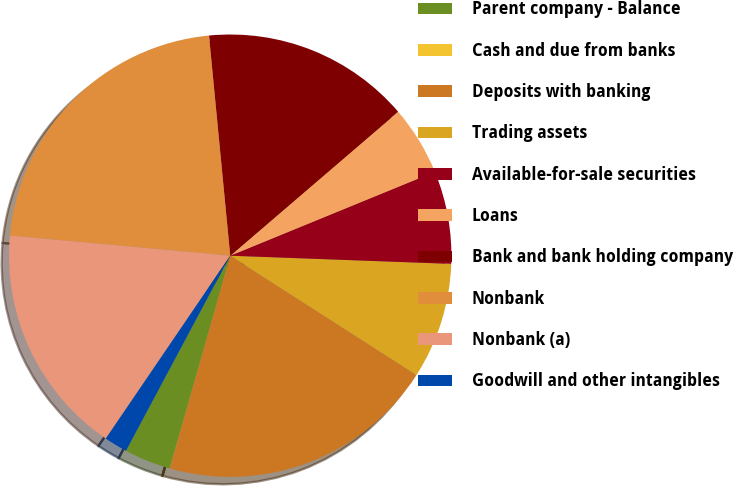Convert chart. <chart><loc_0><loc_0><loc_500><loc_500><pie_chart><fcel>Parent company - Balance<fcel>Cash and due from banks<fcel>Deposits with banking<fcel>Trading assets<fcel>Available-for-sale securities<fcel>Loans<fcel>Bank and bank holding company<fcel>Nonbank<fcel>Nonbank (a)<fcel>Goodwill and other intangibles<nl><fcel>3.4%<fcel>0.01%<fcel>20.33%<fcel>8.48%<fcel>6.78%<fcel>5.09%<fcel>15.25%<fcel>22.02%<fcel>16.94%<fcel>1.7%<nl></chart> 